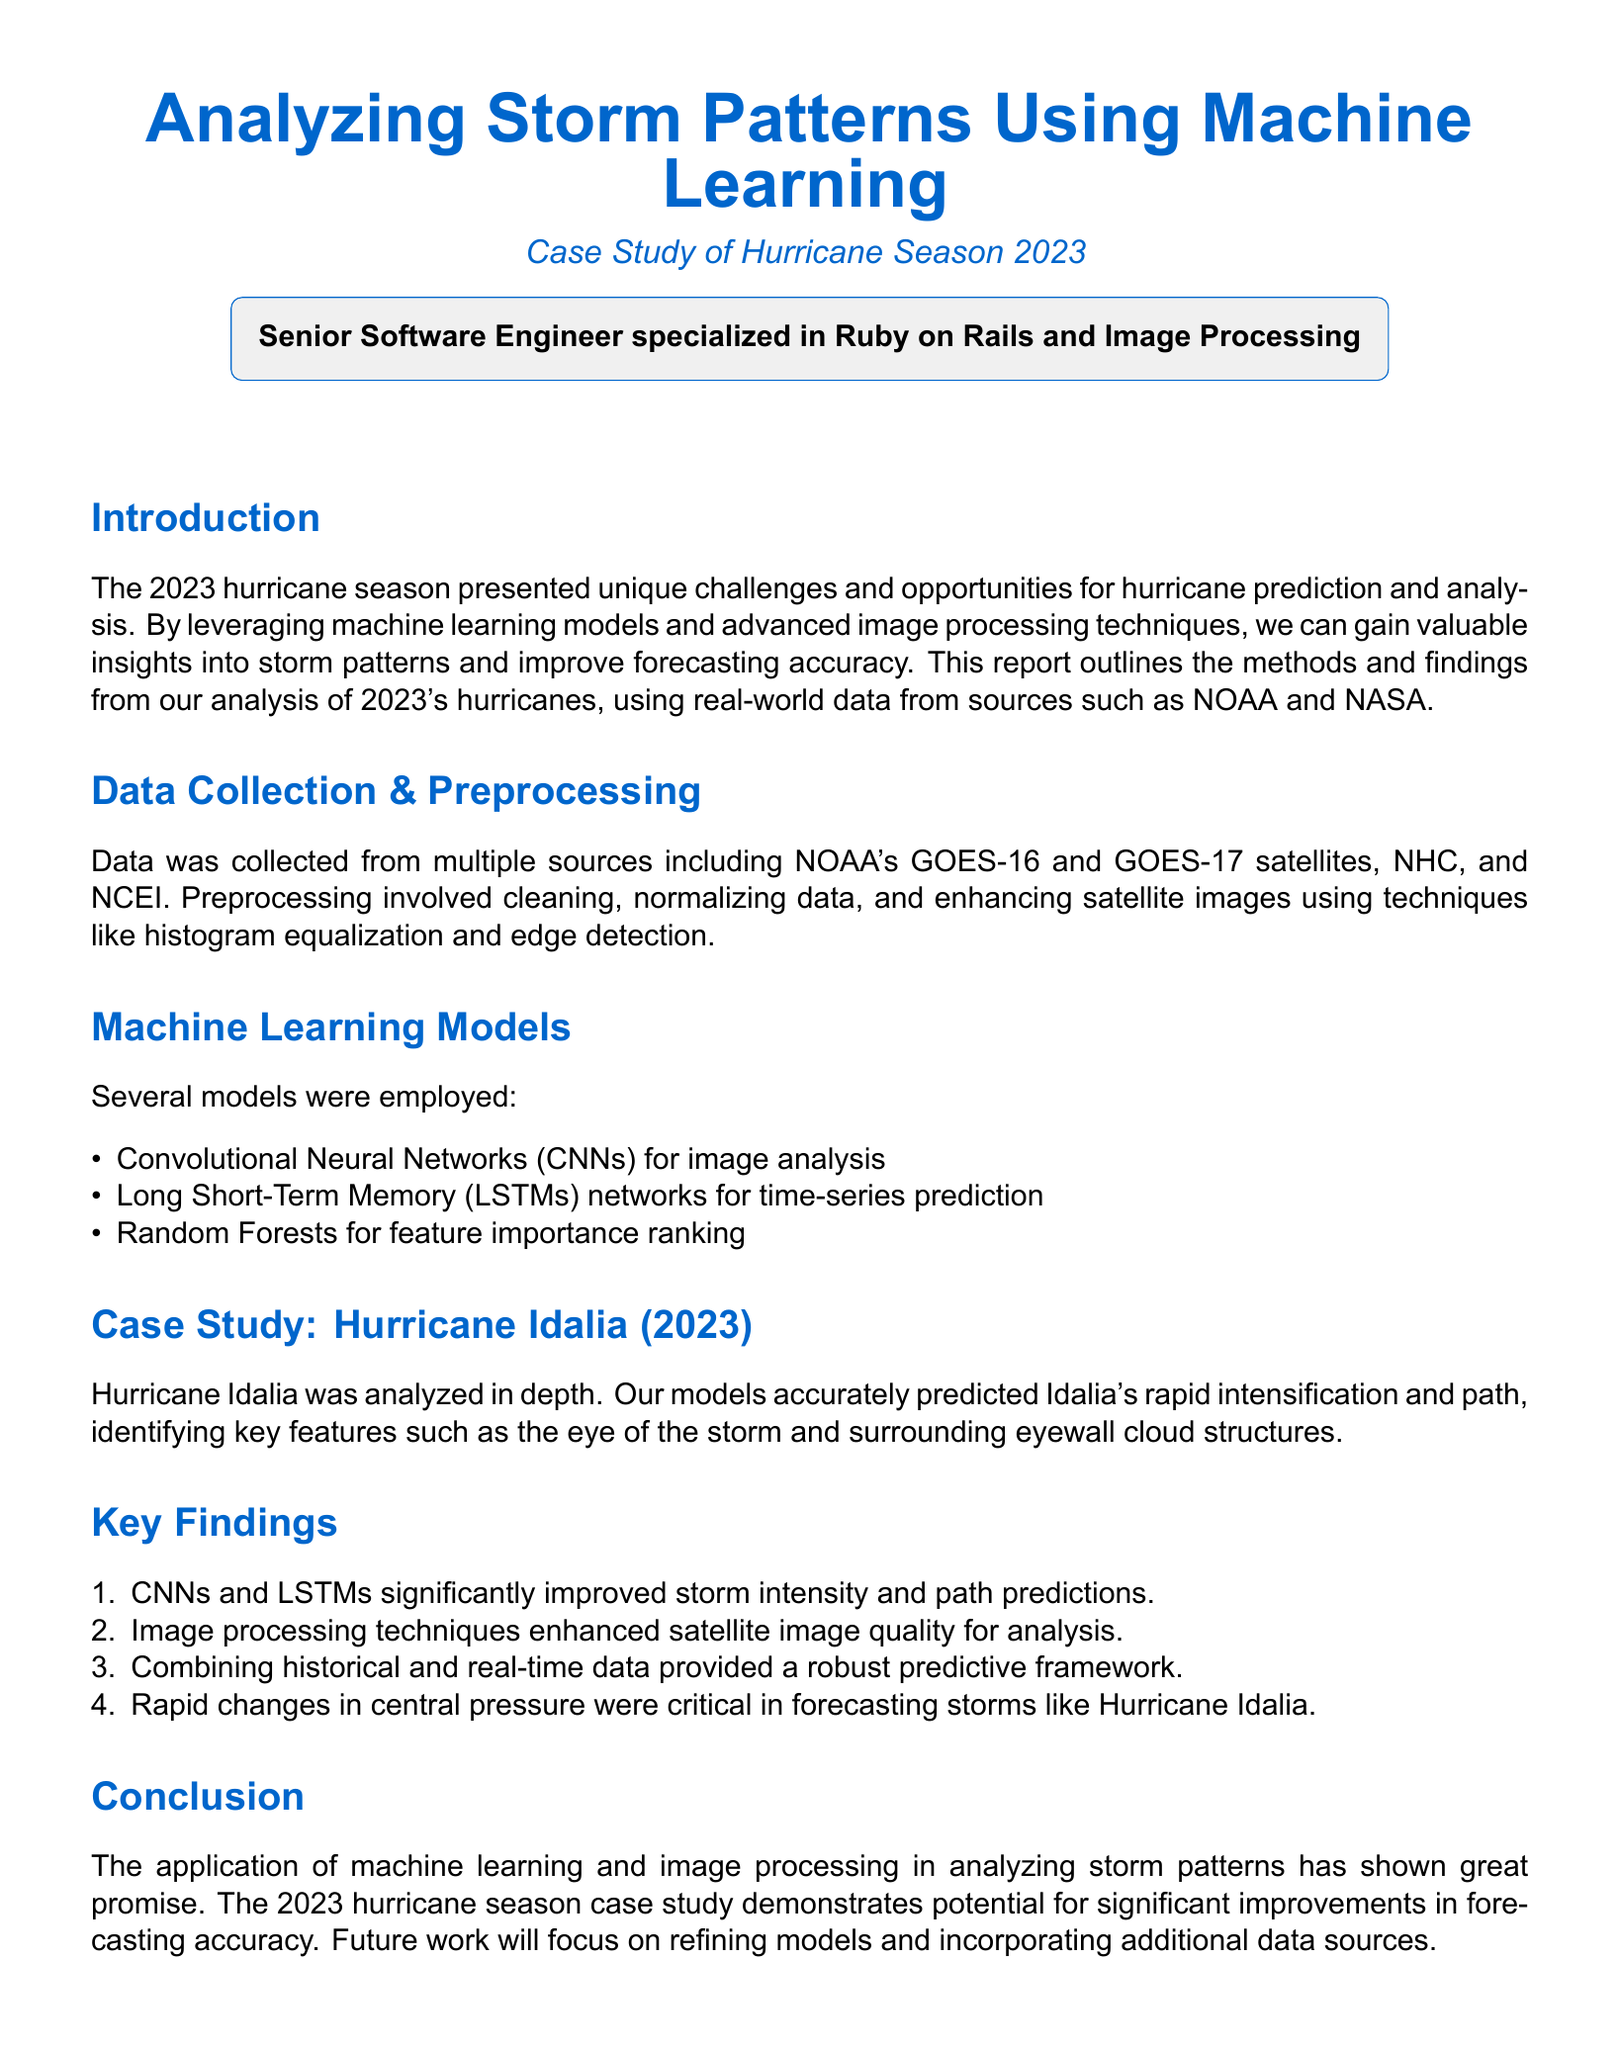What was the primary focus of the report? The report primarily focuses on the analysis of storm patterns using machine learning during the hurricane season of 2023.
Answer: Analyzing storm patterns using machine learning Which hurricane was specifically analyzed in this case study? The case study specifically analyzed Hurricane Idalia during the 2023 hurricane season.
Answer: Hurricane Idalia What type of neural network was used for image analysis? The report mentions that Convolutional Neural Networks (CNNs) were employed for image analysis.
Answer: Convolutional Neural Networks What significant improvement was noted from using CNNs and LSTMs? The report states that CNNs and LSTMs significantly improved storm intensity and path predictions.
Answer: Storm intensity and path predictions What technique was used to enhance satellite images? Histogram equalization and edge detection were used to enhance satellite images in the preprocessing stage.
Answer: Histogram equalization and edge detection What was identified as critical for forecasting storms like Hurricane Idalia? The report highlights that rapid changes in central pressure were critical in forecasting storms like Hurricane Idalia.
Answer: Rapid changes in central pressure From which sources was data collected? Data was collected from multiple sources including NOAA's GOES-16 and GOES-17 satellites, NHC, and NCEI.
Answer: NOAA, NHC, NCEI What is the future focus mentioned in the conclusion? The report concludes with a focus on refining models and incorporating additional data sources as future work.
Answer: Refining models and incorporating additional data sources 